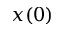<formula> <loc_0><loc_0><loc_500><loc_500>x ( 0 )</formula> 